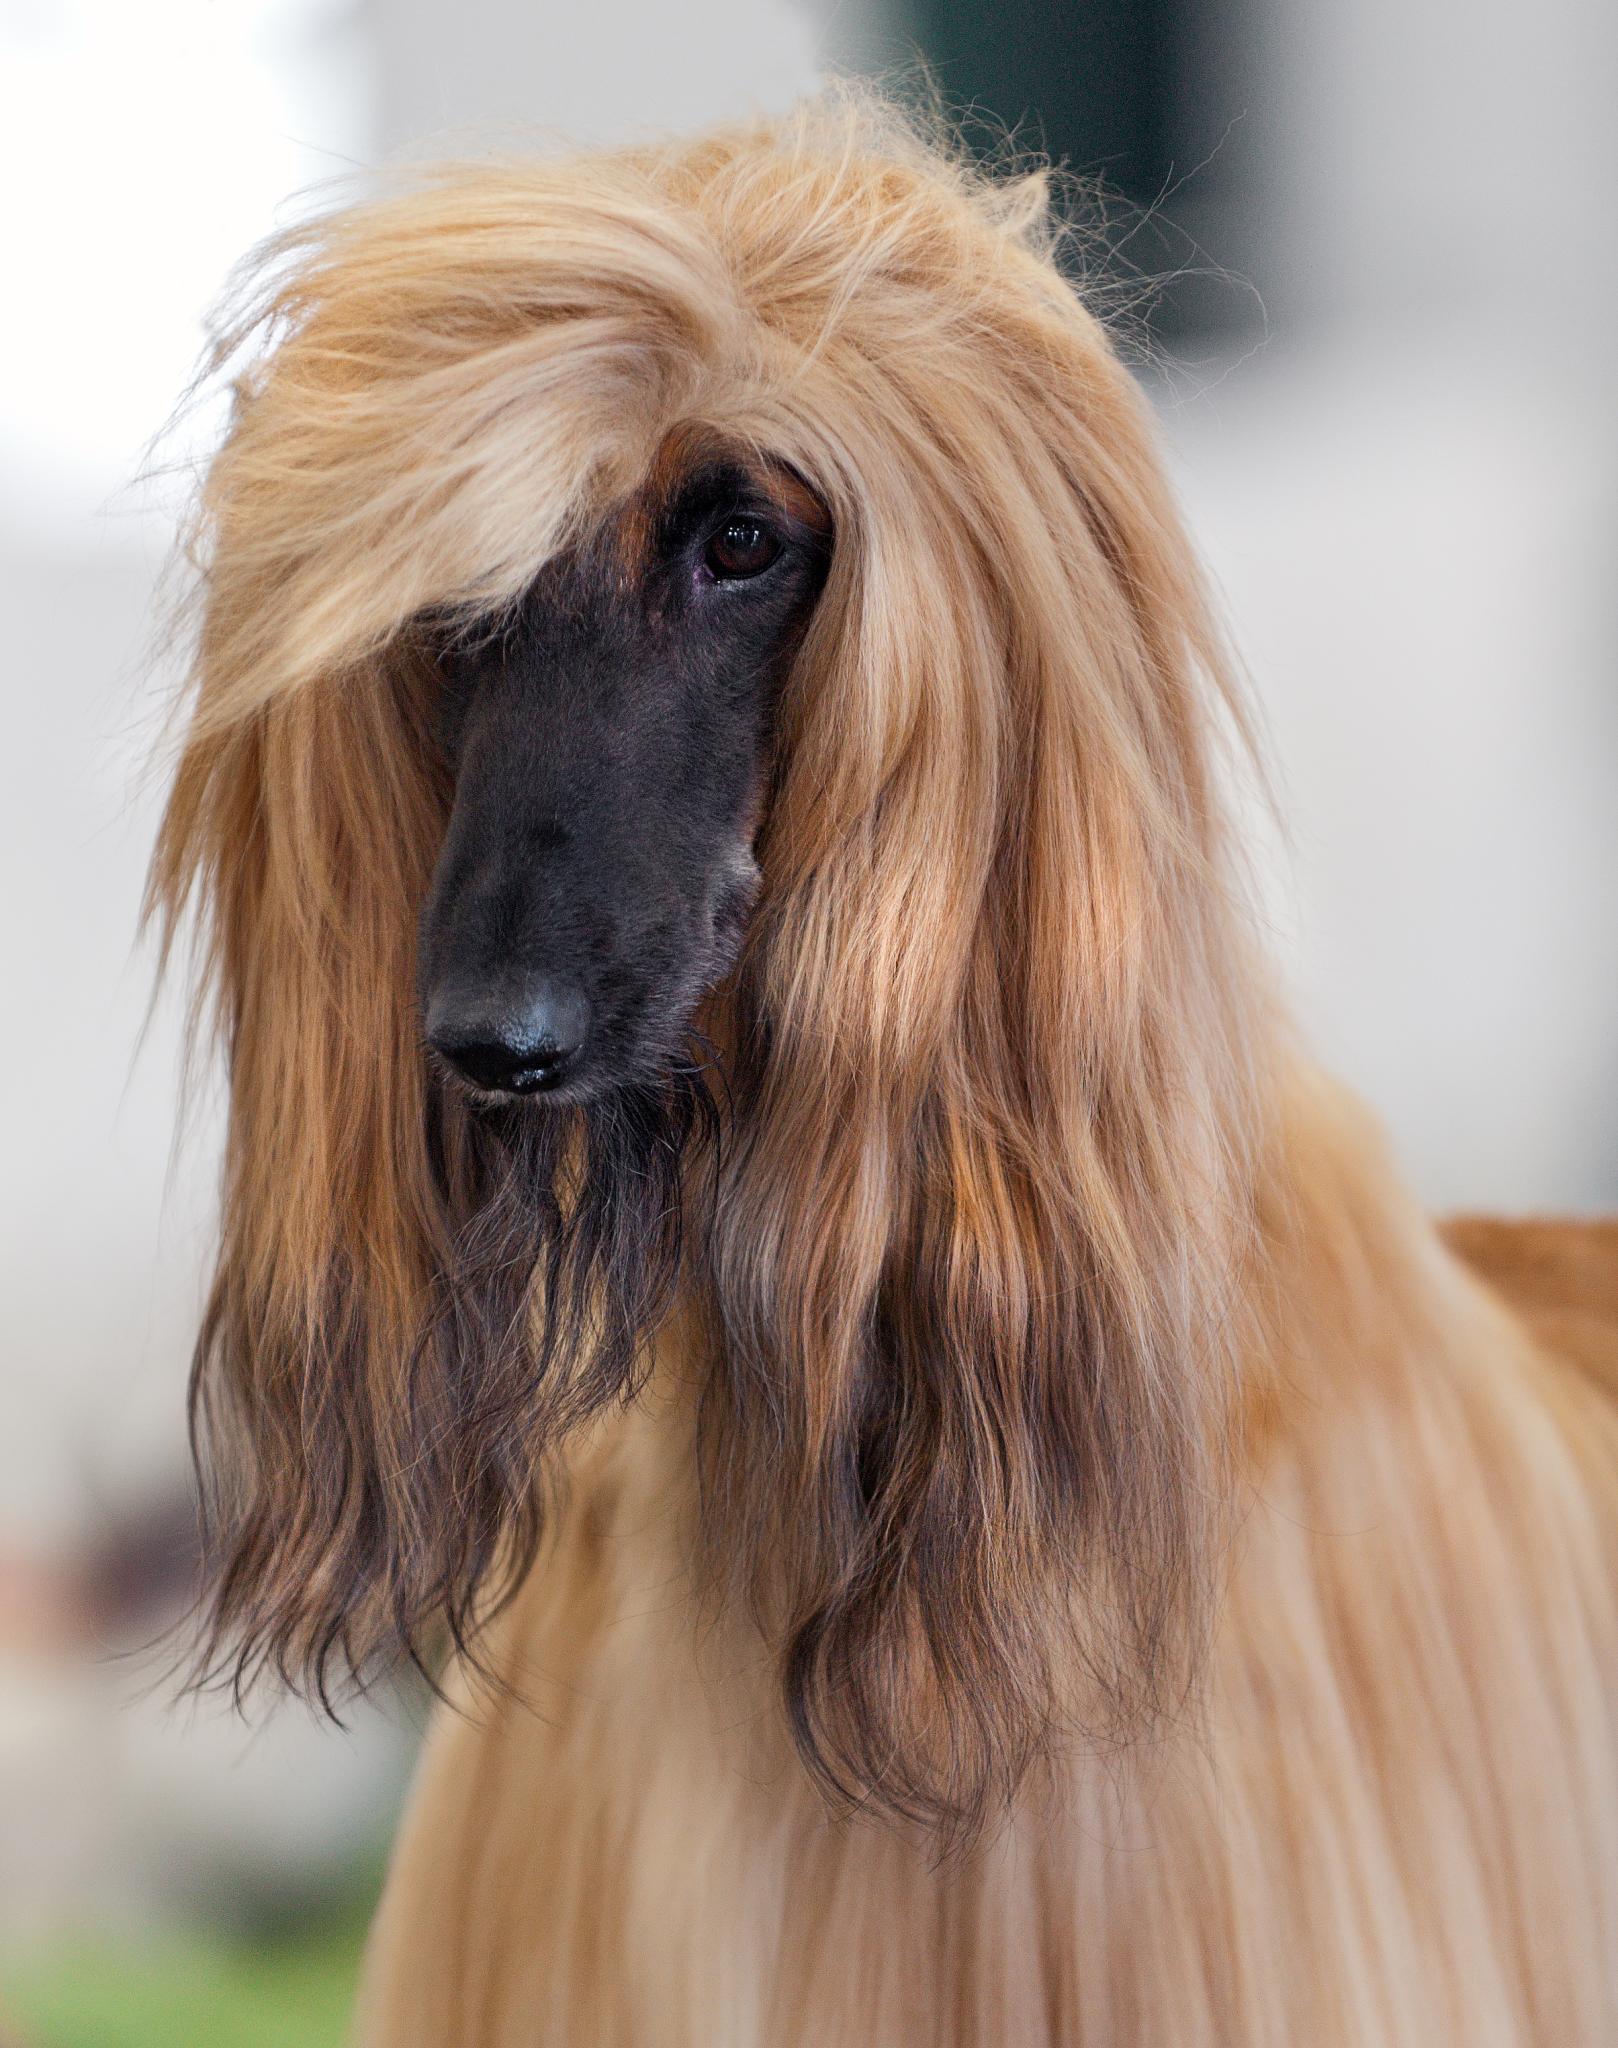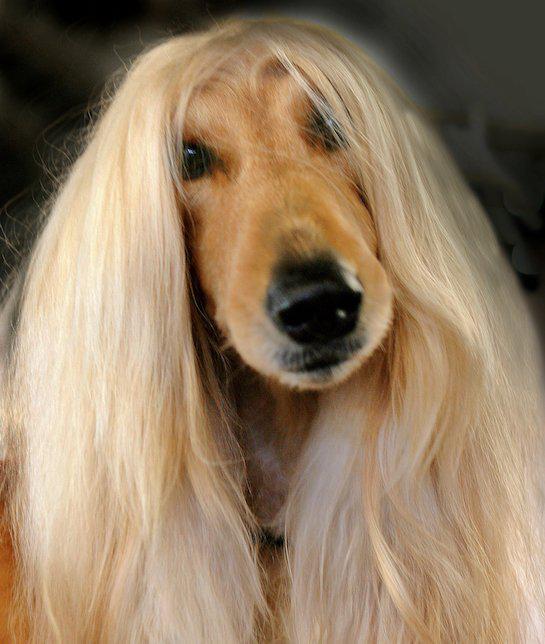The first image is the image on the left, the second image is the image on the right. Examine the images to the left and right. Is the description "The hound on the right has reddish fur on its muzzle instead of a dark muzzle, and blonde hair on top of its head parted down the middle." accurate? Answer yes or no. Yes. The first image is the image on the left, the second image is the image on the right. Examine the images to the left and right. Is the description "All images contain afghan dogs with black snouts." accurate? Answer yes or no. No. 